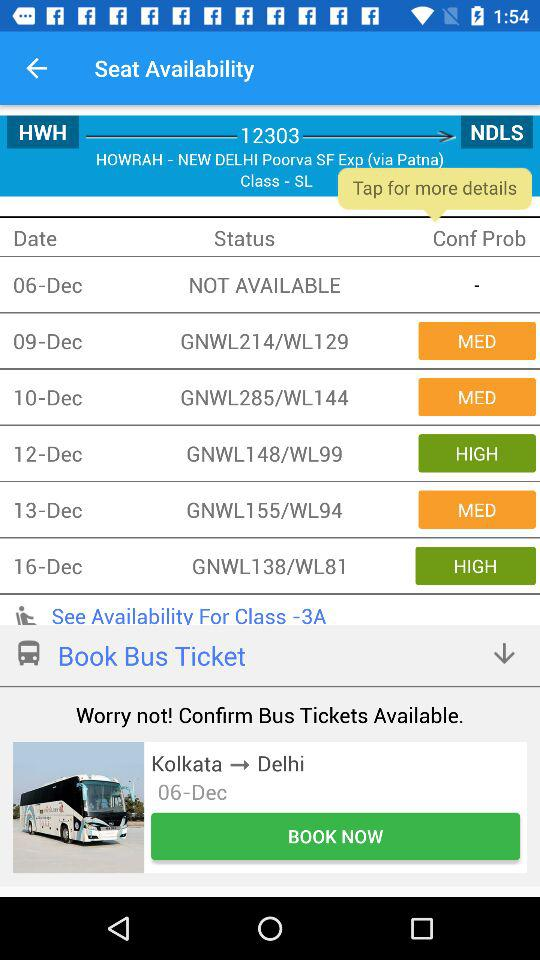What is the status of seat availability on December 12? The status is "GNWL148/WL99". 